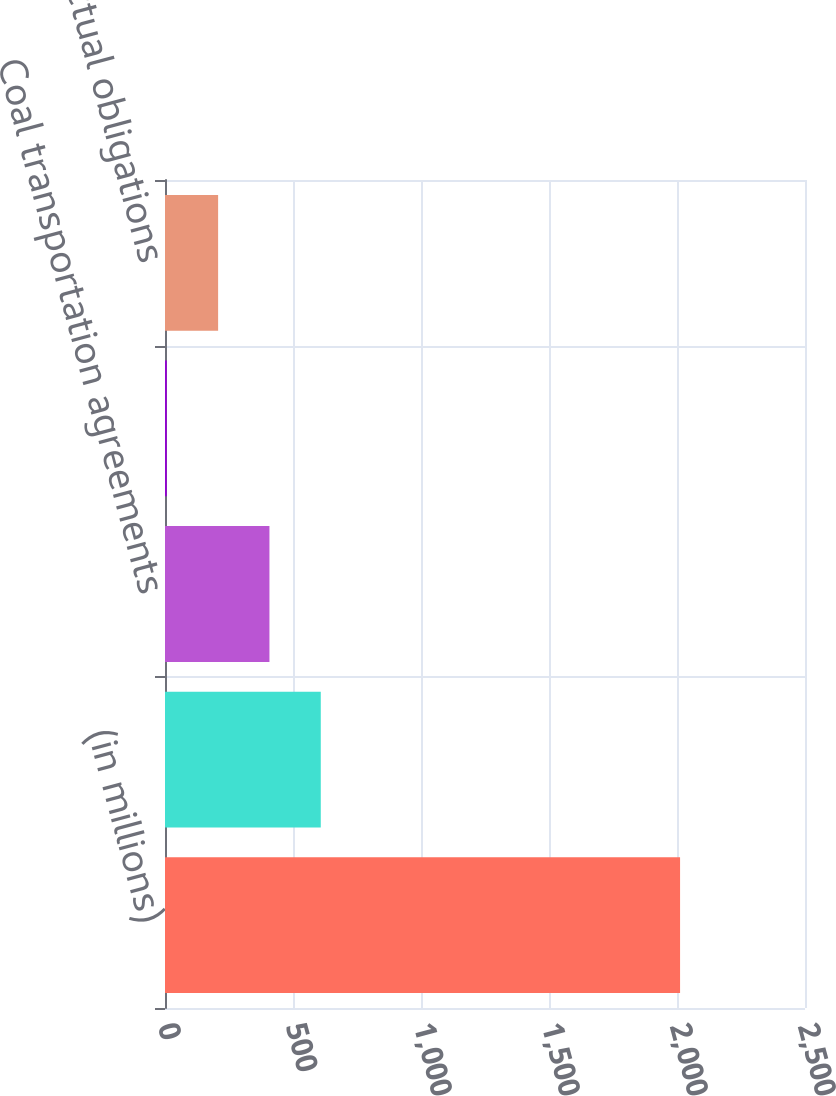Convert chart. <chart><loc_0><loc_0><loc_500><loc_500><bar_chart><fcel>(in millions)<fcel>Other fuel supply contracts<fcel>Coal transportation agreements<fcel>Gas transportation agreements<fcel>Other contractual obligations<nl><fcel>2012<fcel>608.5<fcel>408<fcel>7<fcel>207.5<nl></chart> 